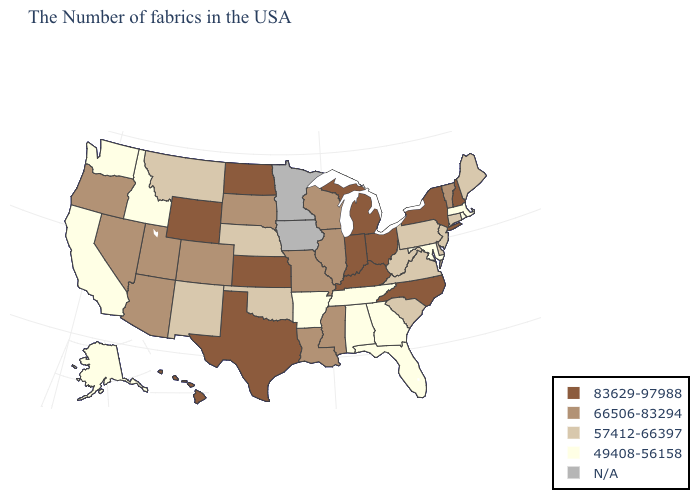Does Ohio have the highest value in the USA?
Short answer required. Yes. Name the states that have a value in the range N/A?
Concise answer only. Minnesota, Iowa. Does Kansas have the highest value in the MidWest?
Be succinct. Yes. Name the states that have a value in the range N/A?
Answer briefly. Minnesota, Iowa. What is the value of Maine?
Concise answer only. 57412-66397. What is the value of North Carolina?
Be succinct. 83629-97988. What is the lowest value in the Northeast?
Answer briefly. 49408-56158. Which states have the highest value in the USA?
Quick response, please. New Hampshire, New York, North Carolina, Ohio, Michigan, Kentucky, Indiana, Kansas, Texas, North Dakota, Wyoming, Hawaii. Name the states that have a value in the range 66506-83294?
Quick response, please. Vermont, Wisconsin, Illinois, Mississippi, Louisiana, Missouri, South Dakota, Colorado, Utah, Arizona, Nevada, Oregon. Name the states that have a value in the range N/A?
Concise answer only. Minnesota, Iowa. How many symbols are there in the legend?
Be succinct. 5. What is the value of Arizona?
Keep it brief. 66506-83294. Among the states that border Massachusetts , which have the lowest value?
Write a very short answer. Rhode Island. Name the states that have a value in the range 57412-66397?
Give a very brief answer. Maine, Connecticut, New Jersey, Delaware, Pennsylvania, Virginia, South Carolina, West Virginia, Nebraska, Oklahoma, New Mexico, Montana. What is the value of Wyoming?
Short answer required. 83629-97988. 